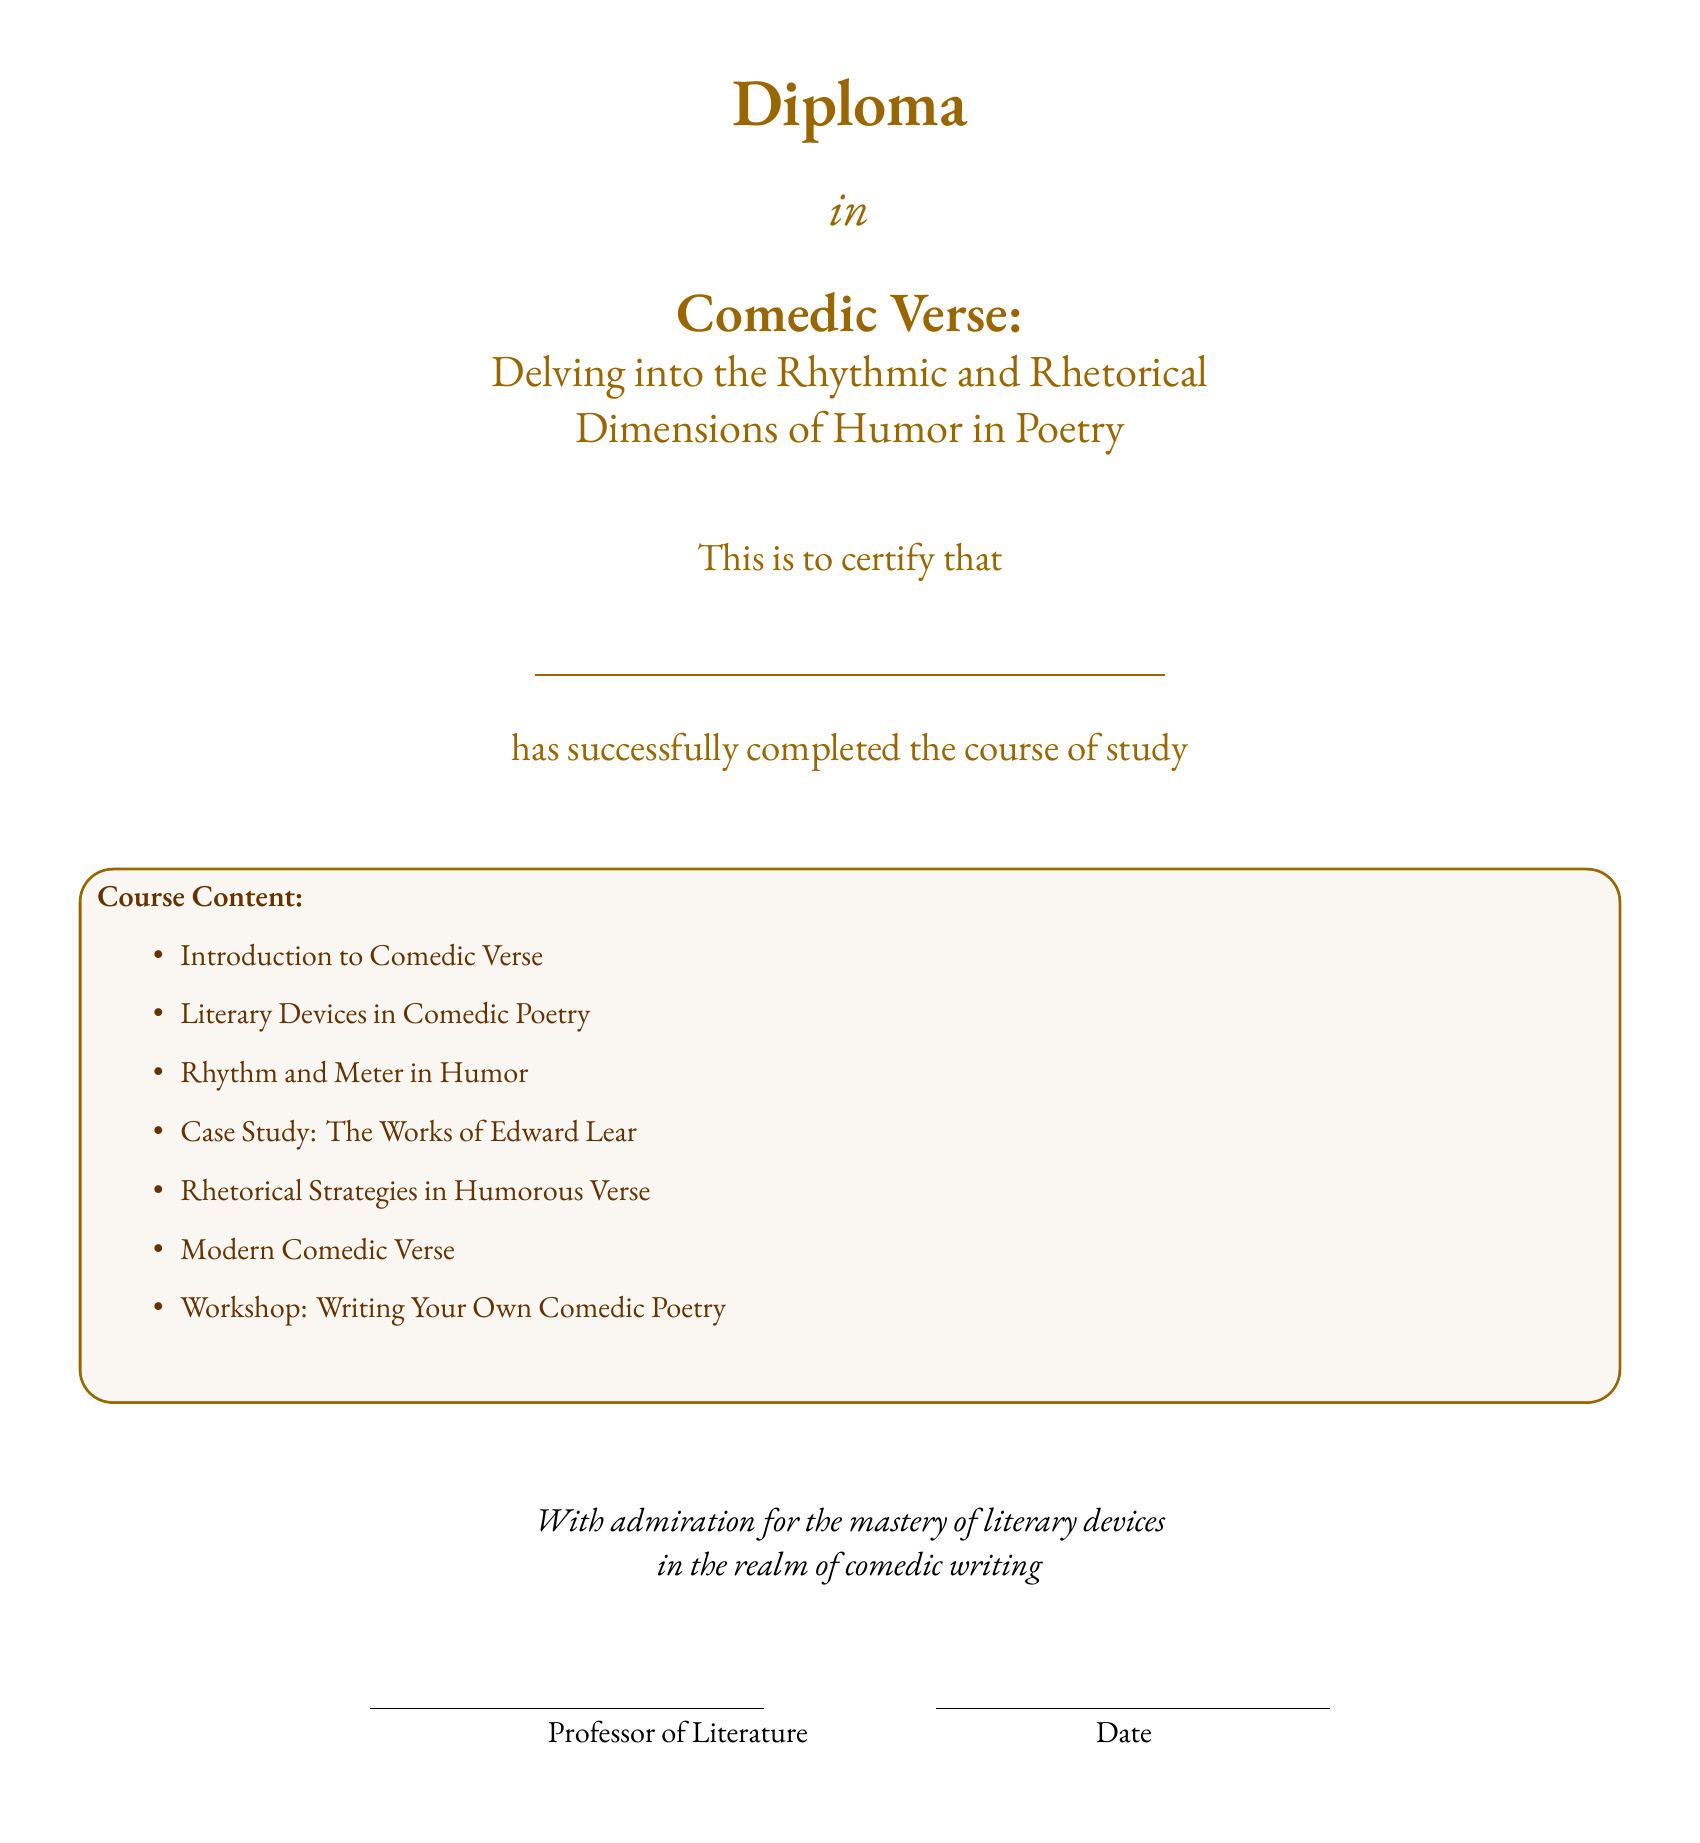What is the title of the diploma? The title is printed prominently in the document, which details the specific focus of the diploma program.
Answer: Comedic Verse: Delving into the Rhythmic and Rhetorical Dimensions of Humor in Poetry Who has completed the course of study? The document has a placeholder for the recipient's name, indicating completion of the course.
Answer: \underline{\hspace{8cm}} What is one of the course content topics? The document lists various topics under course content.
Answer: Literary Devices in Comedic Poetry What literary figure is studied in the case study? The case study section highlights a notable figure in comedic verse, which is a key element of the curriculum.
Answer: Edward Lear What is the primary focus of the diploma? The document specifies the overall theme relevant to the study of humor in poetry.
Answer: Humorous Verse How many main course content items are listed? The document includes a bullet-point list of the topics, allowing for easy counting of the items.
Answer: 7 Who signs the diploma? In the document, there is a designated space for an authority figure to sign as recognition of the accomplishment.
Answer: Professor of Literature What color theme is used in the diploma? The document mentions specific color codes that define its visual identity and aesthetic qualities.
Answer: RGB(153,102,0) and RGB(102,51,0) 